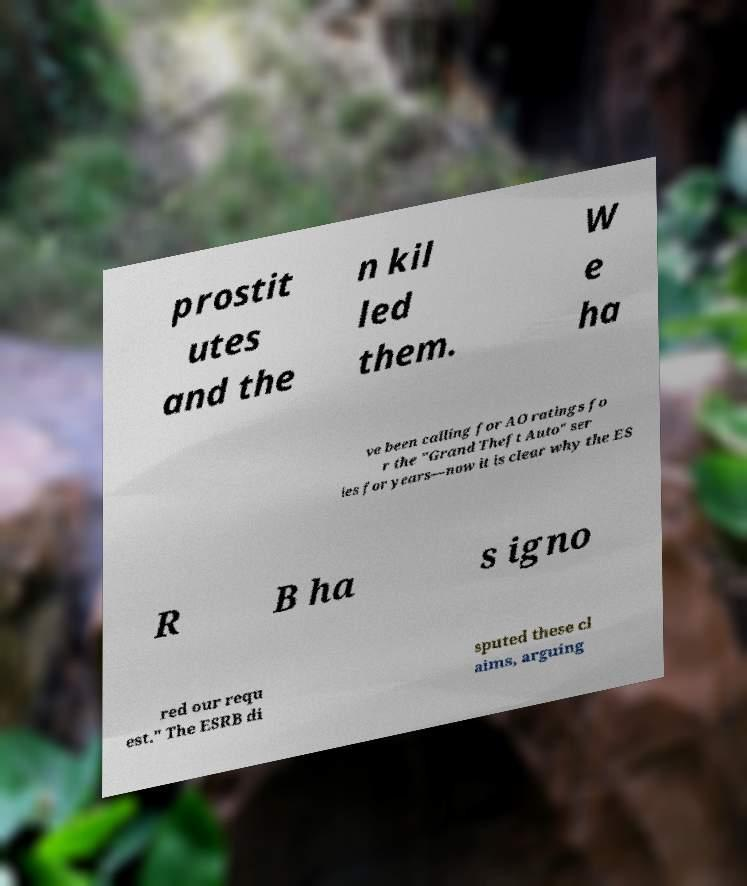Could you extract and type out the text from this image? prostit utes and the n kil led them. W e ha ve been calling for AO ratings fo r the "Grand Theft Auto" ser ies for years—now it is clear why the ES R B ha s igno red our requ est." The ESRB di sputed these cl aims, arguing 